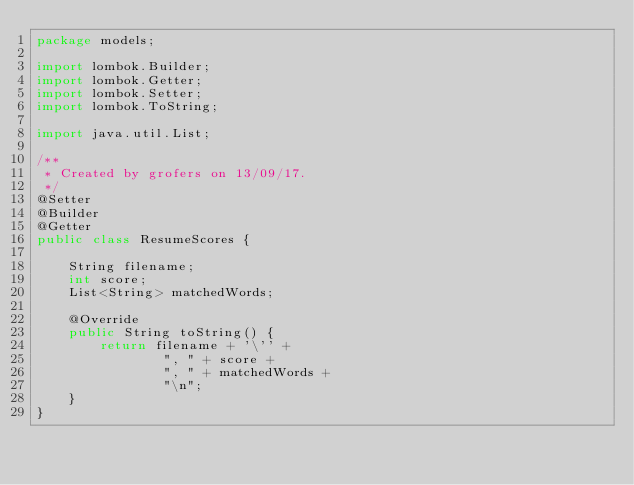Convert code to text. <code><loc_0><loc_0><loc_500><loc_500><_Java_>package models;

import lombok.Builder;
import lombok.Getter;
import lombok.Setter;
import lombok.ToString;

import java.util.List;

/**
 * Created by grofers on 13/09/17.
 */
@Setter
@Builder
@Getter
public class ResumeScores {

    String filename;
    int score;
    List<String> matchedWords;

    @Override
    public String toString() {
        return filename + '\'' +
                ", " + score +
                ", " + matchedWords +
                "\n";
    }
}
</code> 